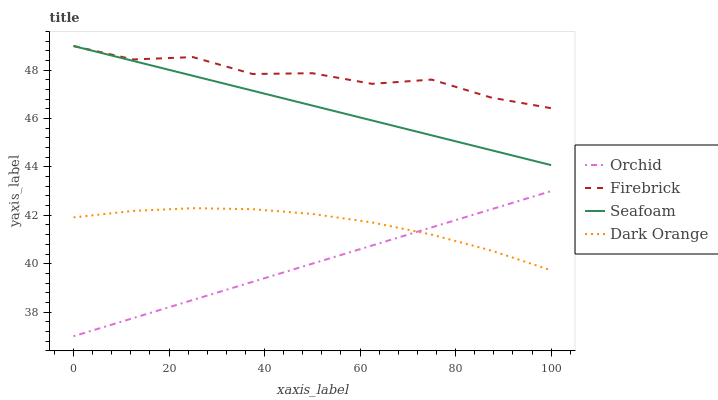Does Orchid have the minimum area under the curve?
Answer yes or no. Yes. Does Firebrick have the maximum area under the curve?
Answer yes or no. Yes. Does Seafoam have the minimum area under the curve?
Answer yes or no. No. Does Seafoam have the maximum area under the curve?
Answer yes or no. No. Is Orchid the smoothest?
Answer yes or no. Yes. Is Firebrick the roughest?
Answer yes or no. Yes. Is Seafoam the smoothest?
Answer yes or no. No. Is Seafoam the roughest?
Answer yes or no. No. Does Orchid have the lowest value?
Answer yes or no. Yes. Does Seafoam have the lowest value?
Answer yes or no. No. Does Seafoam have the highest value?
Answer yes or no. Yes. Does Orchid have the highest value?
Answer yes or no. No. Is Dark Orange less than Seafoam?
Answer yes or no. Yes. Is Seafoam greater than Dark Orange?
Answer yes or no. Yes. Does Dark Orange intersect Orchid?
Answer yes or no. Yes. Is Dark Orange less than Orchid?
Answer yes or no. No. Is Dark Orange greater than Orchid?
Answer yes or no. No. Does Dark Orange intersect Seafoam?
Answer yes or no. No. 